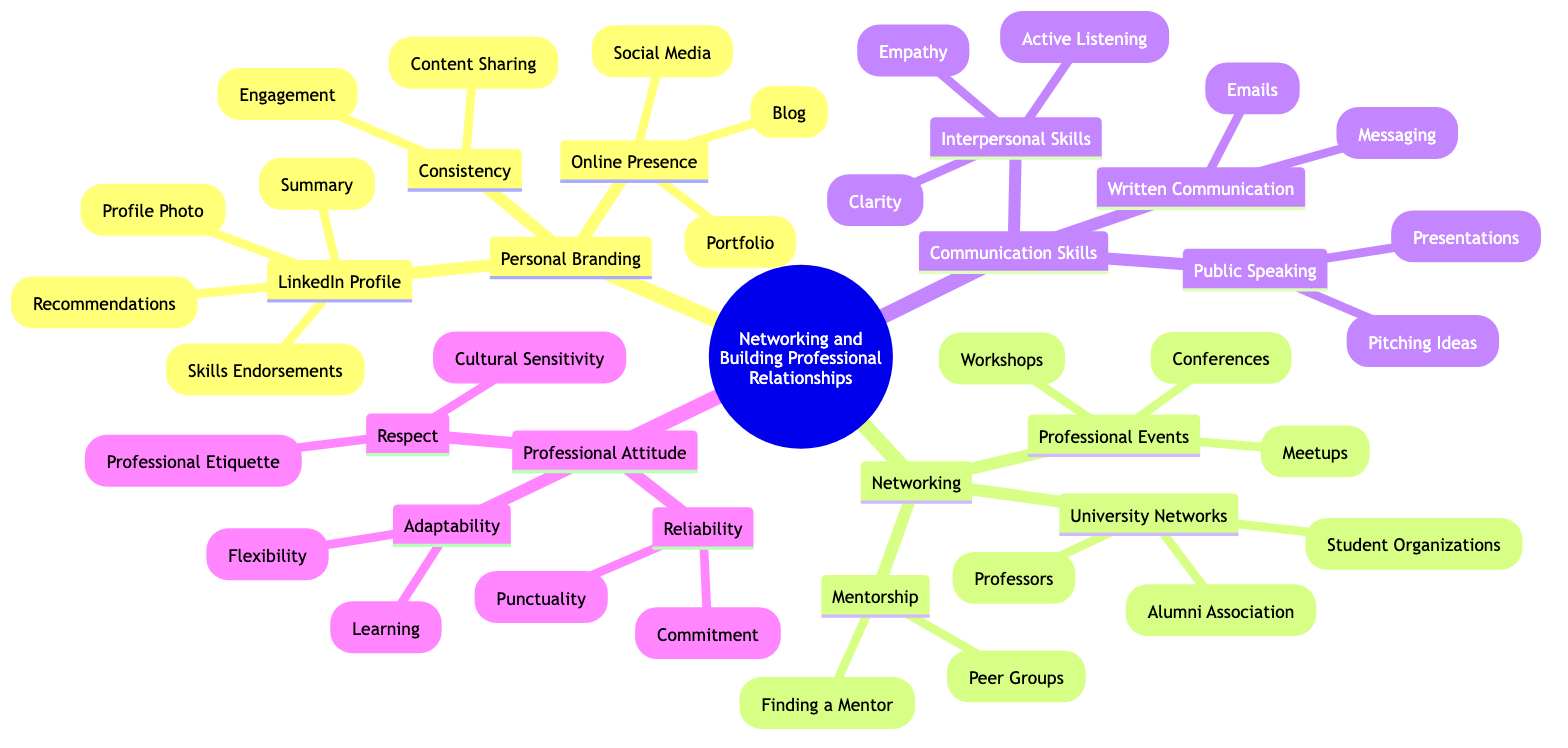What is the main topic of the diagram? The diagram centers around the theme of "Networking and Building Professional Relationships," which is indicated as the root node of the concept map.
Answer: Networking and Building Professional Relationships How many main categories are in the diagram? The diagram includes five main categories: Personal Branding, Networking, Communication Skills, Professional Attitude, and their respective sub-nodes.
Answer: 5 What specific skill is highlighted under Interpersonal Skills? Under Interpersonal Skills, "Active Listening" is mentioned specifically as a significant skill for effective networking and communication.
Answer: Active Listening Which sub-node is associated with Online Presence? The sub-node associated with Online Presence is "Social Media," which is part of Personal Branding in the diagram.
Answer: Social Media What is the relationship between Networking and Professional Events? The relationship indicates that "Professional Events" is a sub-category under "Networking," emphasizing the importance of attending various events for networking purposes.
Answer: Professional Events How does Mentorship relate to Networking? Mentorship is categorized under Networking, demonstrating that finding a mentor and engaging in peer groups are key components of building professional relationships.
Answer: Mentorship What is a key component of Written Communication? A key component under Written Communication is "Emails," which highlights the importance of professional correspondence in networking.
Answer: Emails Name one aspect of Professional Attitude described in the diagram. One aspect described under Professional Attitude is "Reliability," which includes the sub-nodes of "Commitment" and "Punctuality."
Answer: Reliability Which node emphasizes the importance of cultural awareness? The node that emphasizes cultural awareness is "Cultural Sensitivity," which falls under the Respect category in Professional Attitude.
Answer: Cultural Sensitivity 